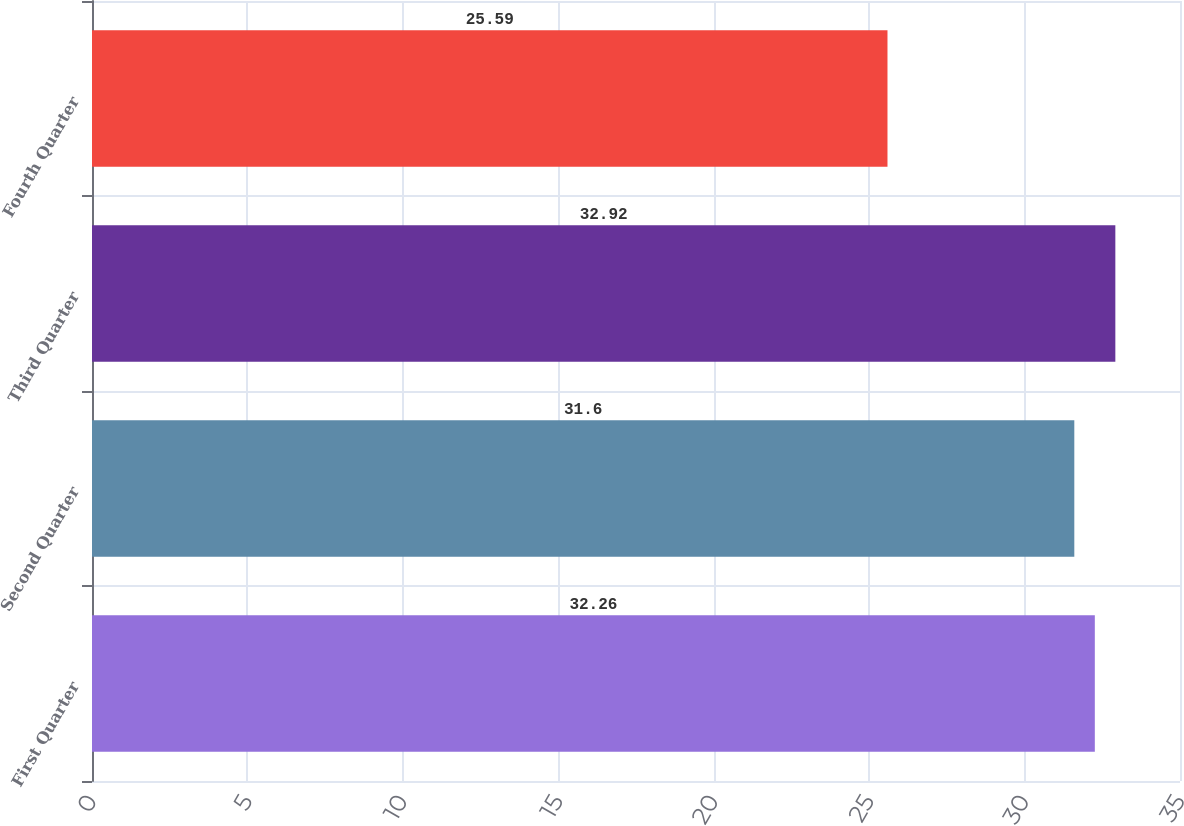Convert chart. <chart><loc_0><loc_0><loc_500><loc_500><bar_chart><fcel>First Quarter<fcel>Second Quarter<fcel>Third Quarter<fcel>Fourth Quarter<nl><fcel>32.26<fcel>31.6<fcel>32.92<fcel>25.59<nl></chart> 